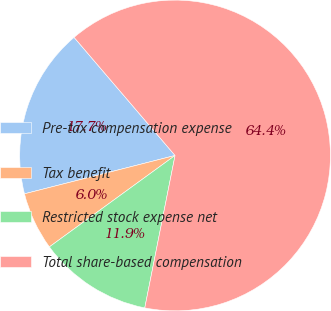Convert chart to OTSL. <chart><loc_0><loc_0><loc_500><loc_500><pie_chart><fcel>Pre-tax compensation expense<fcel>Tax benefit<fcel>Restricted stock expense net<fcel>Total share-based compensation<nl><fcel>17.71%<fcel>6.04%<fcel>11.87%<fcel>64.38%<nl></chart> 